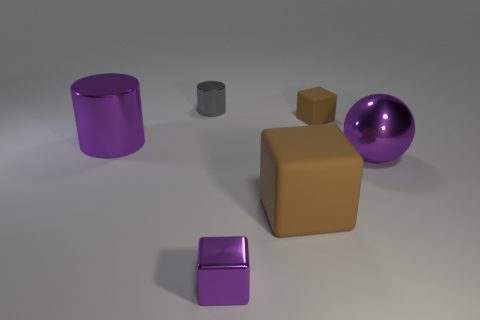Add 4 brown objects. How many objects exist? 10 Subtract all spheres. How many objects are left? 5 Add 6 small metallic objects. How many small metallic objects exist? 8 Subtract 0 green balls. How many objects are left? 6 Subtract all gray cylinders. Subtract all tiny gray things. How many objects are left? 4 Add 1 tiny matte things. How many tiny matte things are left? 2 